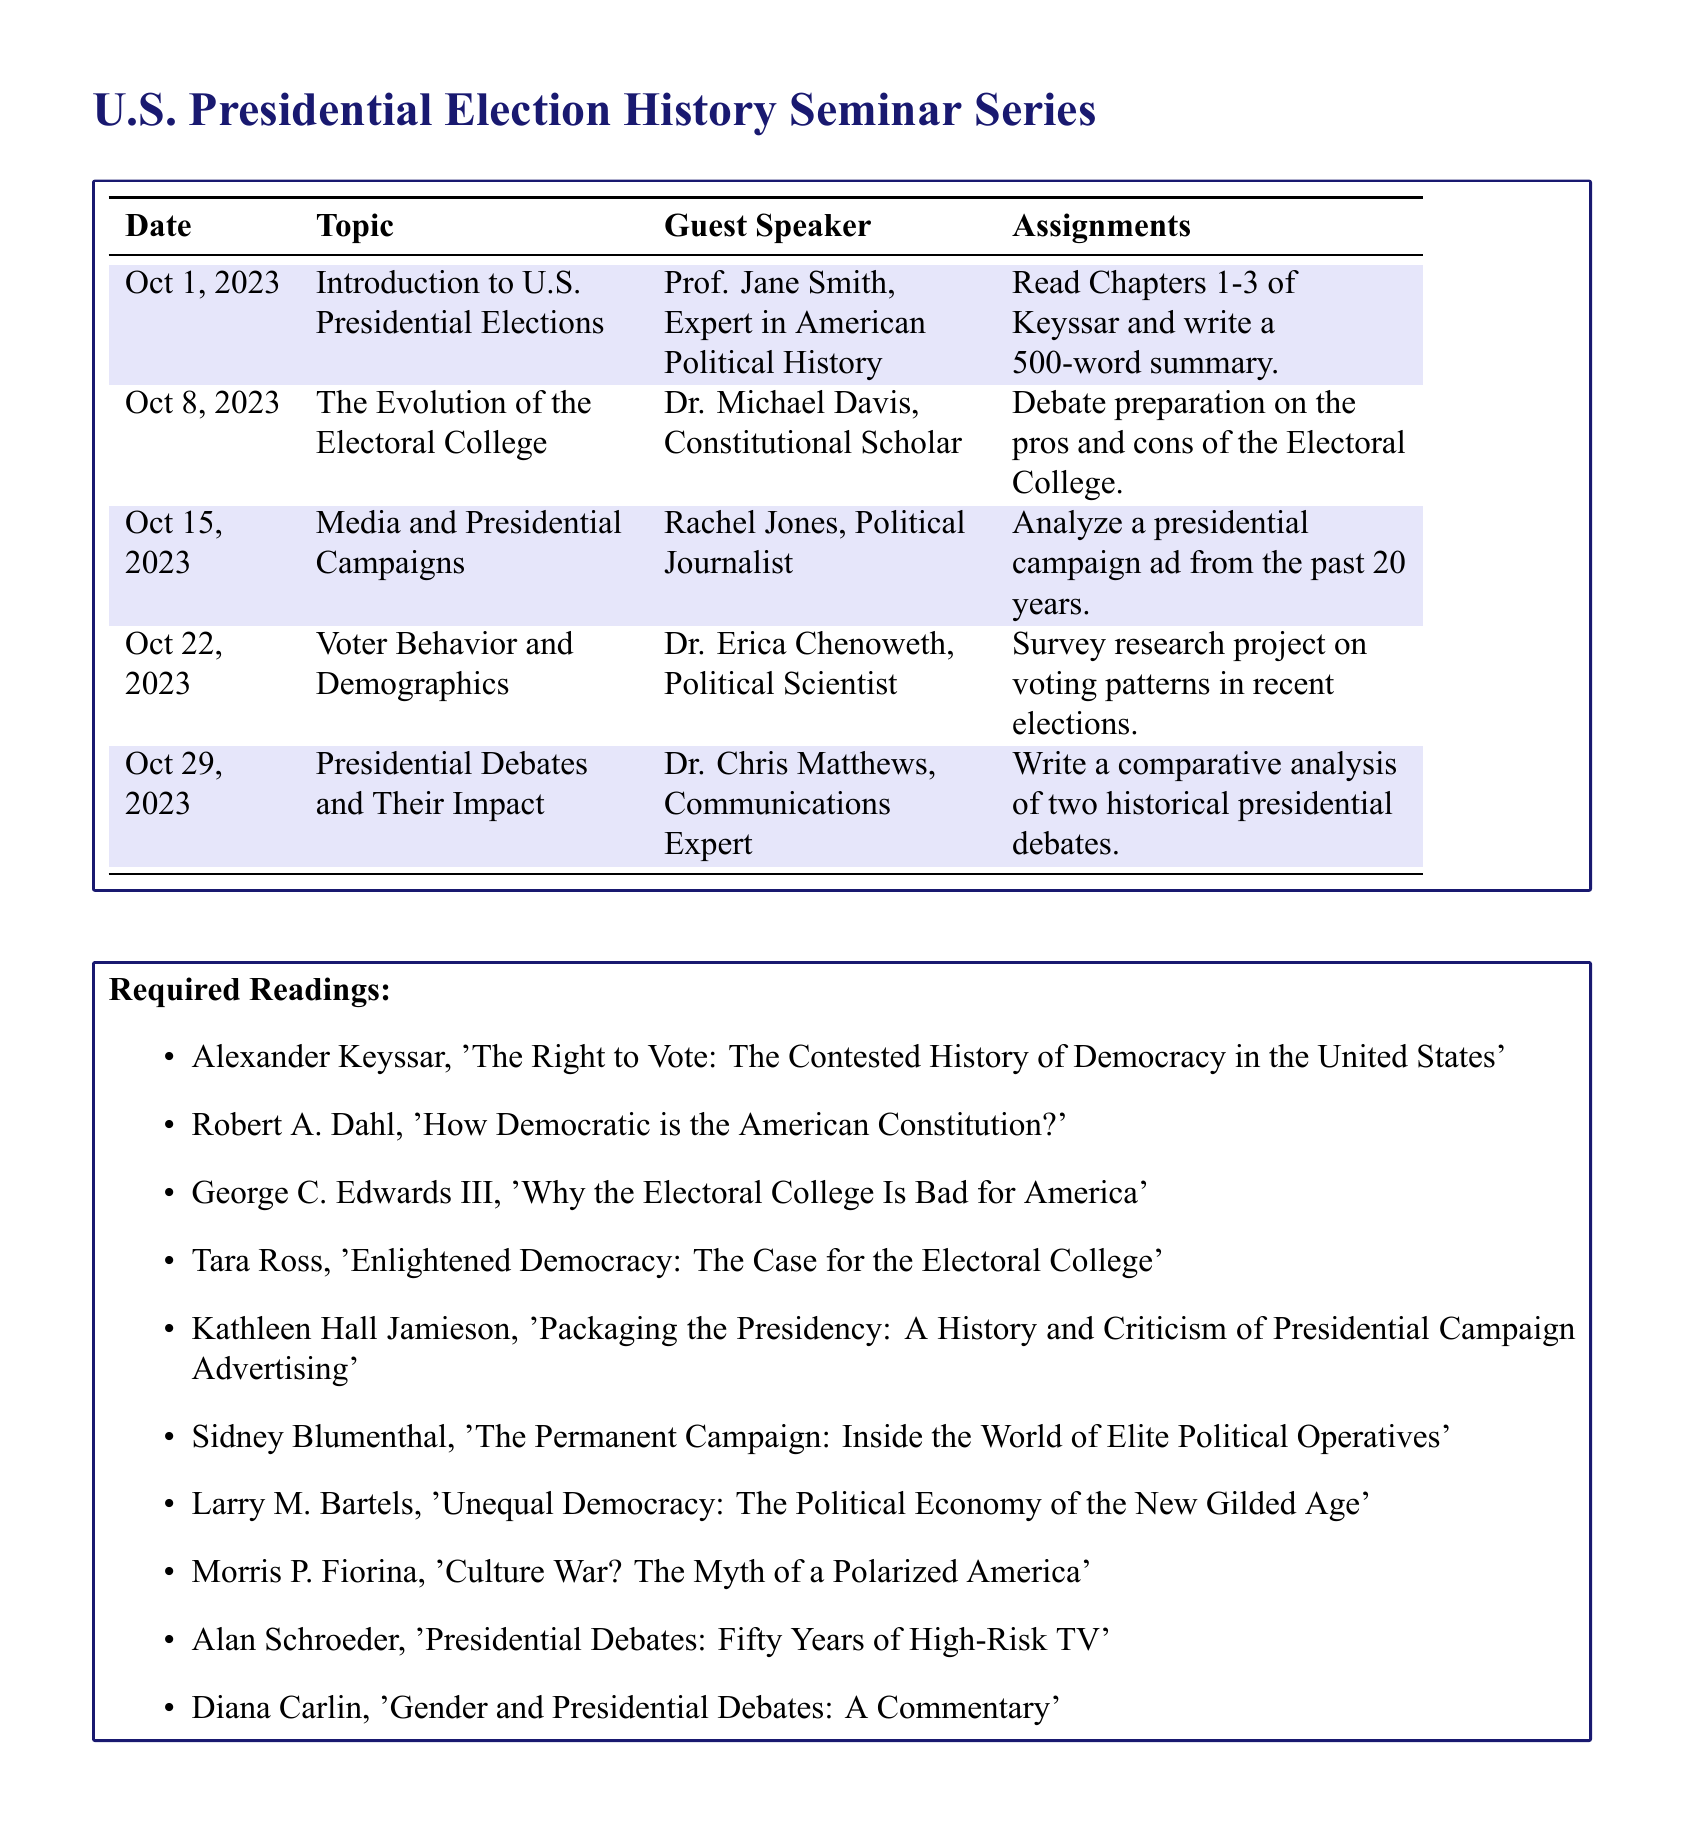What is the date of the first seminar? The first seminar is scheduled for October 1, 2023, as listed in the document.
Answer: October 1, 2023 Who is the guest speaker for the seminar on voter behavior? The seminar on voter behavior and demographics features Dr. Erica Chenoweth as the guest speaker.
Answer: Dr. Erica Chenoweth What assignment is due for the seminar on presidential debates? For the seminar on presidential debates, the assignment is to write a comparative analysis of two historical presidential debates.
Answer: Write a comparative analysis of two historical presidential debates What is the topic covered in the seminar on October 8, 2023? The seminar scheduled for October 8, 2023, will discuss "The Evolution of the Electoral College."
Answer: The Evolution of the Electoral College How many required readings are listed in the document? The document lists ten required readings related to U.S. presidential election history.
Answer: Ten What type of project is assigned for the seminar on voter behavior? The assignment for the seminar on voter behavior is a survey research project on voting patterns in recent elections.
Answer: Survey research project on voting patterns in recent elections Which guest speaker specializes in communications? Dr. Chris Matthews is identified as the communications expert guest speaker in the seminar series.
Answer: Dr. Chris Matthews 